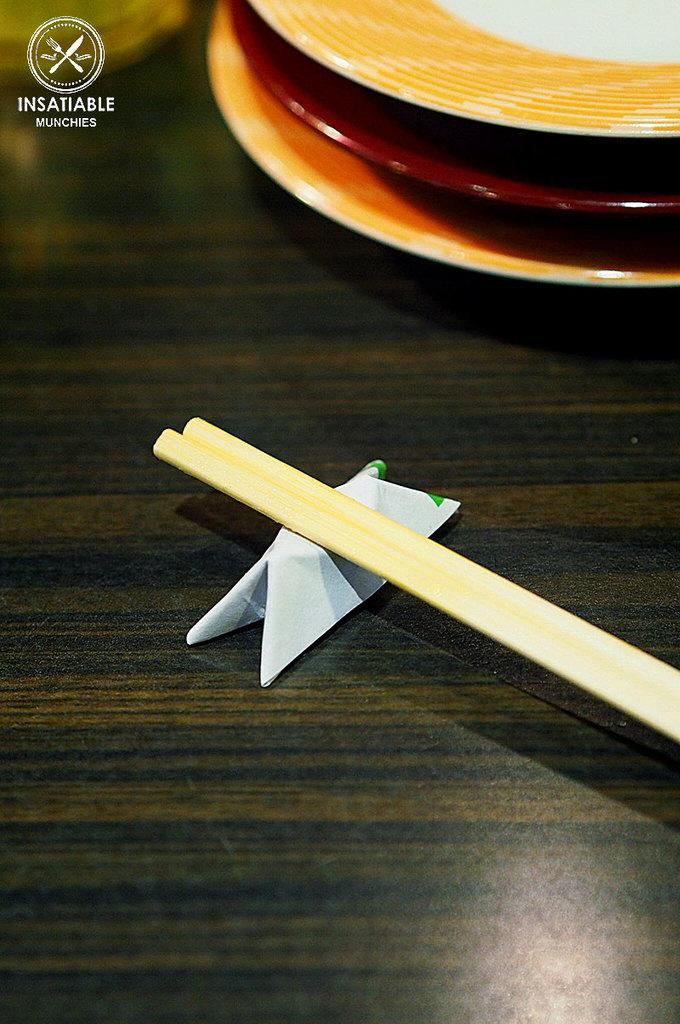What utensils can be seen in the image? There are chopsticks in the image. What type of dishware is present in the image? There are plates in the image. What type of shoe is visible in the image? There is no shoe present in the image. How many grapes are on the plate in the image? There is no plate with grapes present in the image. 